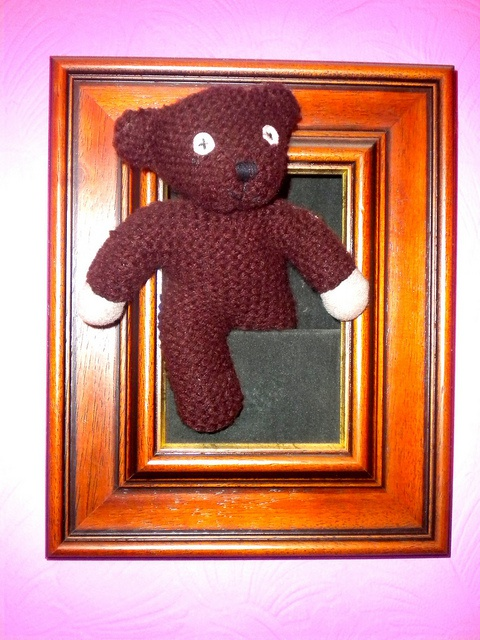Describe the objects in this image and their specific colors. I can see a teddy bear in violet, maroon, brown, and white tones in this image. 